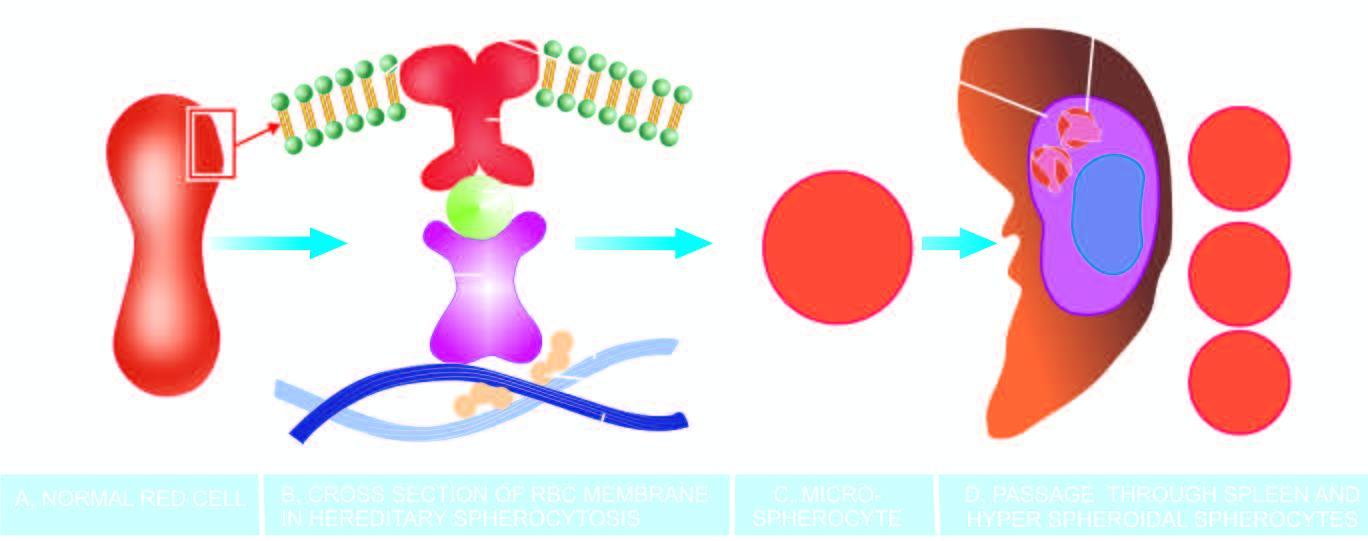these rigid spherical cells lose whose cell membrane further during passage through the spleen?
Answer the question using a single word or phrase. Their 